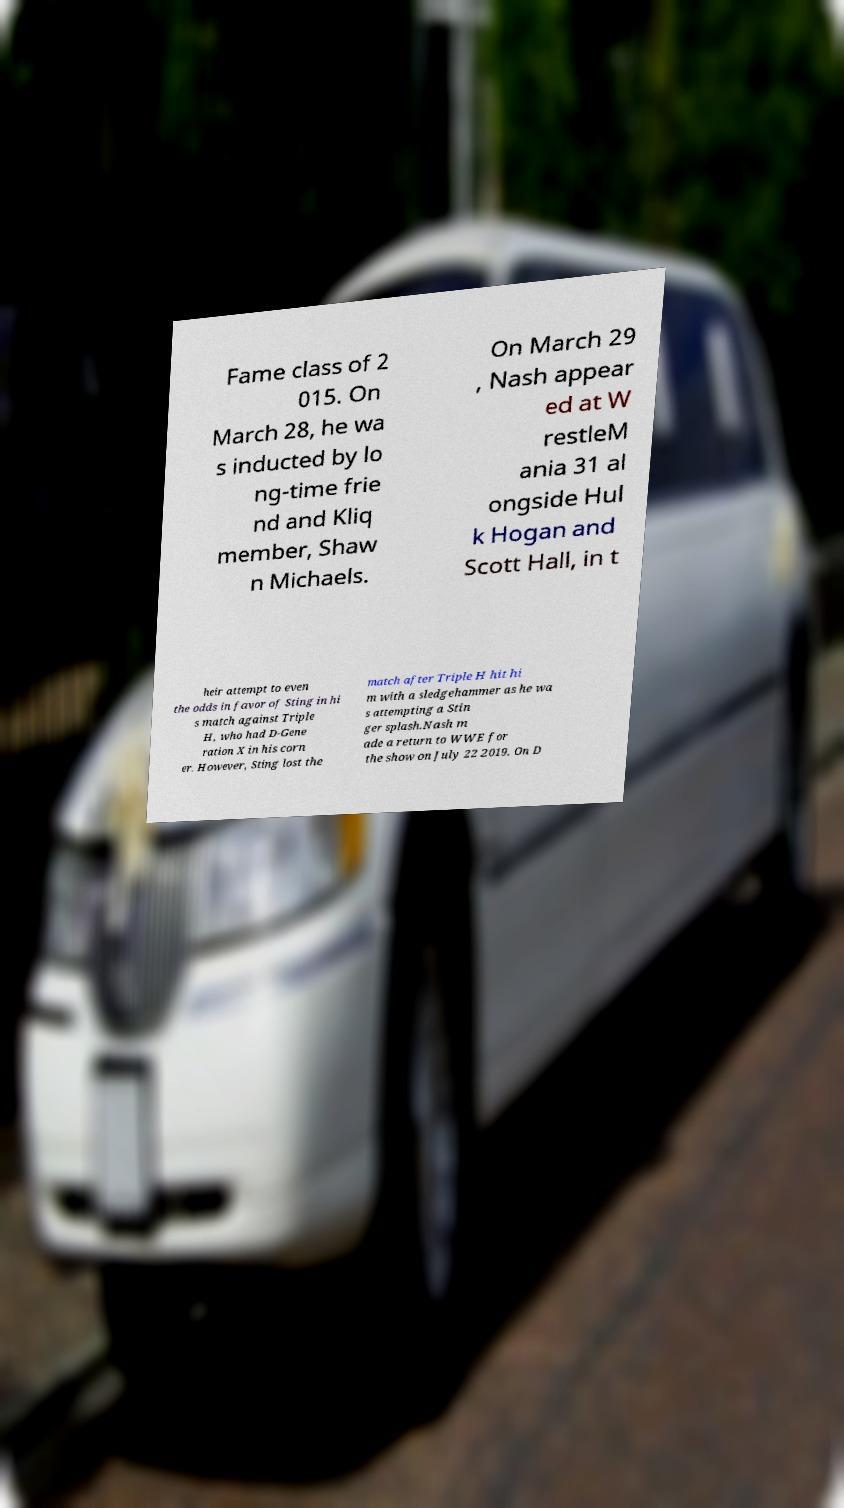For documentation purposes, I need the text within this image transcribed. Could you provide that? Fame class of 2 015. On March 28, he wa s inducted by lo ng-time frie nd and Kliq member, Shaw n Michaels. On March 29 , Nash appear ed at W restleM ania 31 al ongside Hul k Hogan and Scott Hall, in t heir attempt to even the odds in favor of Sting in hi s match against Triple H, who had D-Gene ration X in his corn er. However, Sting lost the match after Triple H hit hi m with a sledgehammer as he wa s attempting a Stin ger splash.Nash m ade a return to WWE for the show on July 22 2019. On D 